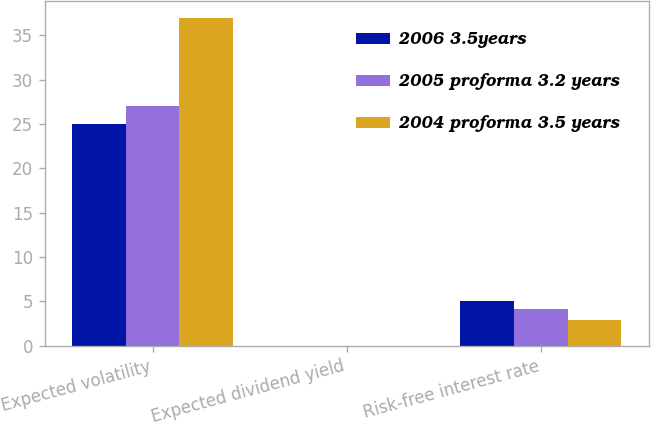<chart> <loc_0><loc_0><loc_500><loc_500><stacked_bar_chart><ecel><fcel>Expected volatility<fcel>Expected dividend yield<fcel>Risk-free interest rate<nl><fcel>2006 3.5years<fcel>25<fcel>0<fcel>5<nl><fcel>2005 proforma 3.2 years<fcel>27<fcel>0<fcel>4.1<nl><fcel>2004 proforma 3.5 years<fcel>37<fcel>0<fcel>2.9<nl></chart> 